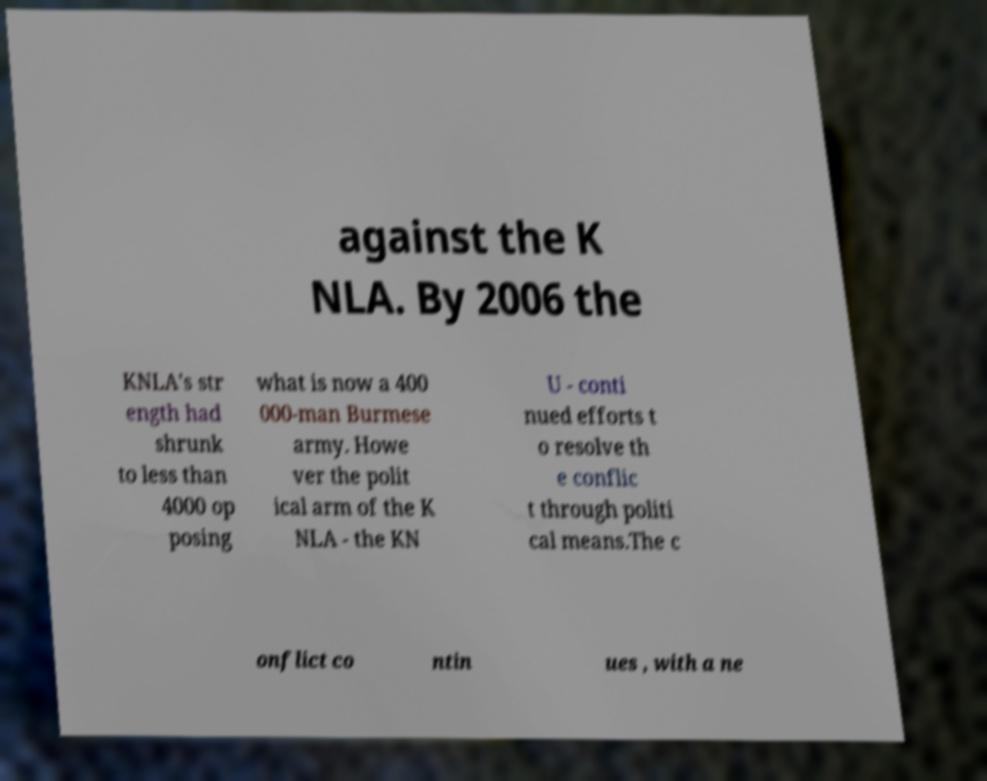For documentation purposes, I need the text within this image transcribed. Could you provide that? against the K NLA. By 2006 the KNLA's str ength had shrunk to less than 4000 op posing what is now a 400 000-man Burmese army. Howe ver the polit ical arm of the K NLA - the KN U - conti nued efforts t o resolve th e conflic t through politi cal means.The c onflict co ntin ues , with a ne 